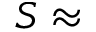Convert formula to latex. <formula><loc_0><loc_0><loc_500><loc_500>S \approx</formula> 